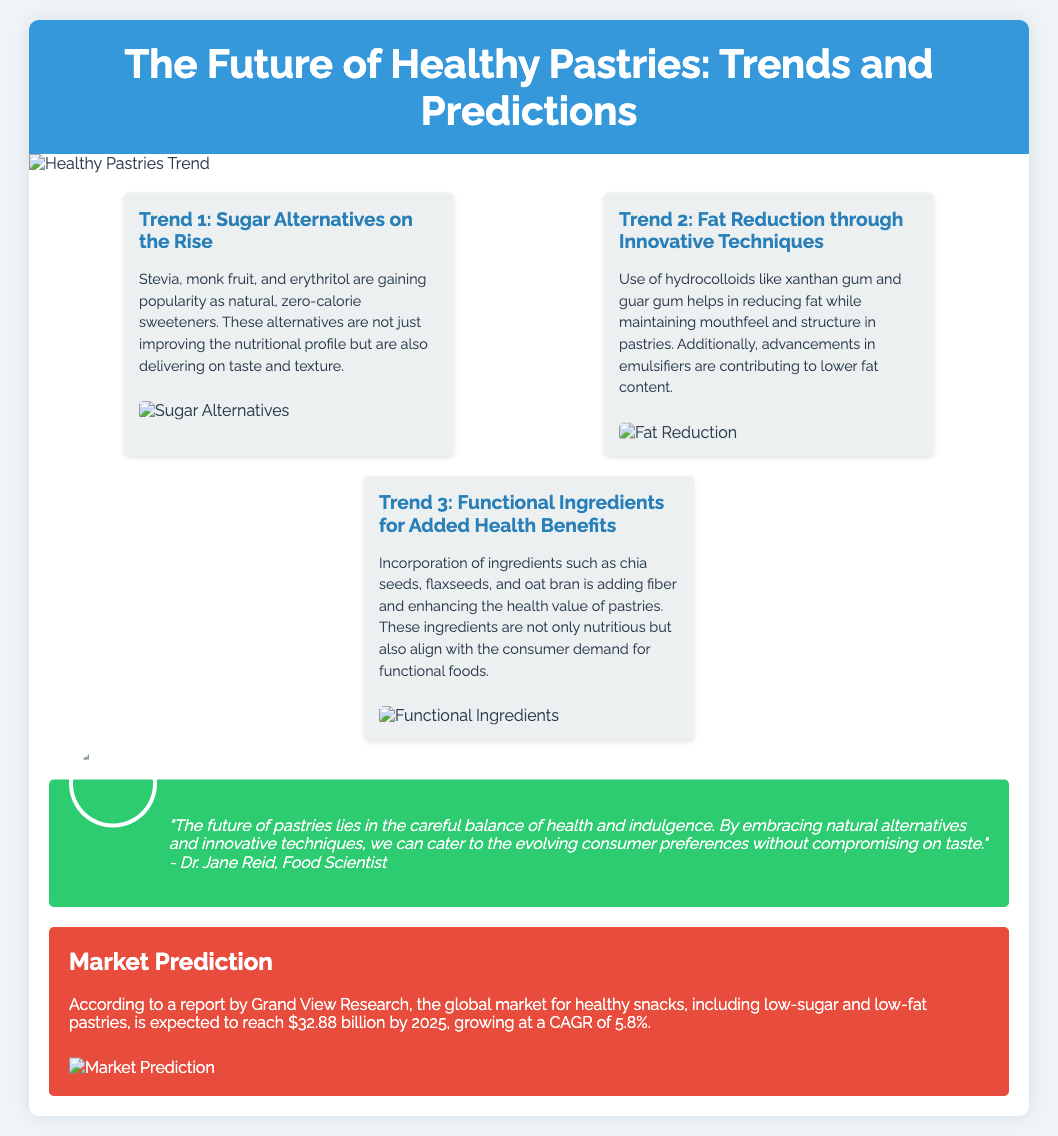What is the title of the flyer? The title of the flyer is indicated at the top, prominently displayed in large text.
Answer: The Future of Healthy Pastries: Trends and Predictions Who is the expert quoted in the document? The expert is mentioned in a dedicated section that highlights their quote and image.
Answer: Dr. Jane Reid What is the first trend mentioned in the flyer? The first trend is detailed in its own section with a heading and description.
Answer: Sugar Alternatives on the Rise What natural ingredient is mentioned as a sugar alternative? The document states specific sugar alternatives in the description.
Answer: Stevia What is the projected market value for healthy snacks by 2025? The market prediction section provides a specific monetary figure for future growth.
Answer: $32.88 billion What is the anticipated CAGR for the healthy snacks market? The CAGR is specifically stated in the market prediction section.
Answer: 5.8% Which ingredient is suggested for fat reduction in pastries? The document lists specific ingredients that contribute to fat reduction in the second trend's description.
Answer: Hydrocolloids What health benefit do chia seeds provide according to the flyer? The content describes the purpose of adding chia seeds within the context of dietary enhancements.
Answer: Added fiber 